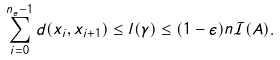Convert formula to latex. <formula><loc_0><loc_0><loc_500><loc_500>\sum _ { i = 0 } ^ { n _ { e } - 1 } d ( x _ { i } , x _ { i + 1 } ) \leq l ( \gamma ) \leq ( 1 - \epsilon ) n \mathcal { I } ( A ) .</formula> 